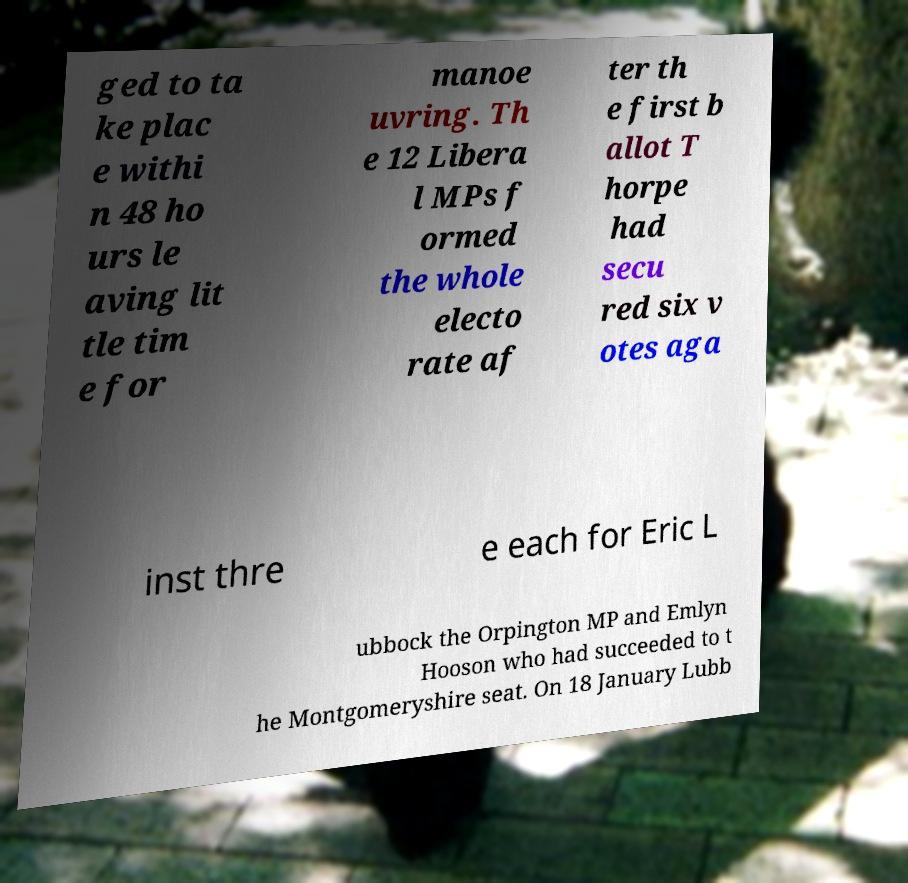Please read and relay the text visible in this image. What does it say? ged to ta ke plac e withi n 48 ho urs le aving lit tle tim e for manoe uvring. Th e 12 Libera l MPs f ormed the whole electo rate af ter th e first b allot T horpe had secu red six v otes aga inst thre e each for Eric L ubbock the Orpington MP and Emlyn Hooson who had succeeded to t he Montgomeryshire seat. On 18 January Lubb 